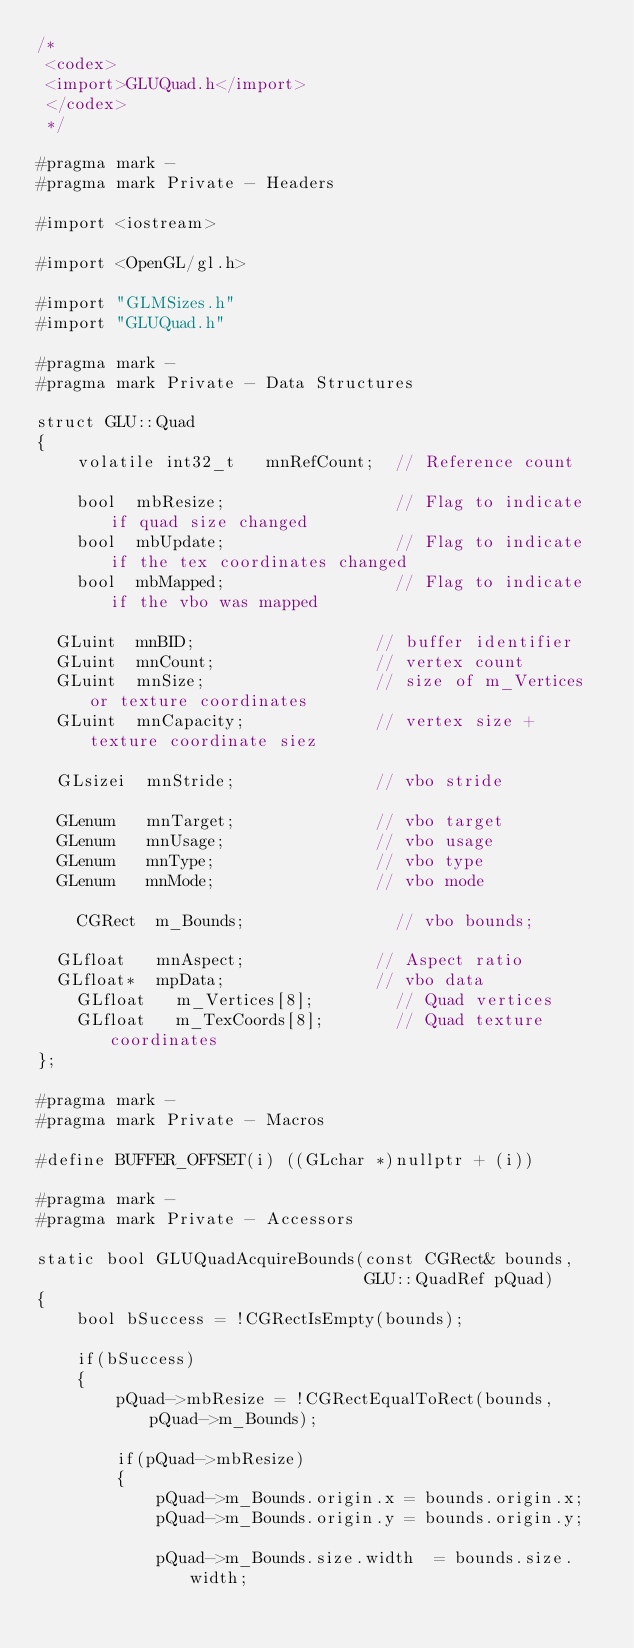Convert code to text. <code><loc_0><loc_0><loc_500><loc_500><_ObjectiveC_>/*
 <codex>
 <import>GLUQuad.h</import>
 </codex>
 */

#pragma mark -
#pragma mark Private - Headers

#import <iostream>

#import <OpenGL/gl.h>

#import "GLMSizes.h"
#import "GLUQuad.h"

#pragma mark -
#pragma mark Private - Data Structures

struct GLU::Quad
{
    volatile int32_t   mnRefCount;  // Reference count
    
    bool  mbResize;                 // Flag to indicate if quad size changed
    bool  mbUpdate;                 // Flag to indicate if the tex coordinates changed
    bool  mbMapped;                 // Flag to indicate if the vbo was mapped
    
	GLuint  mnBID;                  // buffer identifier
	GLuint  mnCount;                // vertex count
	GLuint  mnSize;                 // size of m_Vertices or texture coordinates
	GLuint  mnCapacity;             // vertex size + texture coordinate siez
    
	GLsizei  mnStride;              // vbo stride
    
	GLenum   mnTarget;              // vbo target
	GLenum   mnUsage;               // vbo usage
	GLenum   mnType;                // vbo type
	GLenum   mnMode;                // vbo mode
    
    CGRect  m_Bounds;               // vbo bounds;
    
	GLfloat   mnAspect;             // Aspect ratio
	GLfloat*  mpData;               // vbo data
    GLfloat   m_Vertices[8];        // Quad vertices
    GLfloat   m_TexCoords[8];       // Quad texture coordinates
};

#pragma mark -
#pragma mark Private - Macros

#define BUFFER_OFFSET(i) ((GLchar *)nullptr + (i))

#pragma mark -
#pragma mark Private - Accessors

static bool GLUQuadAcquireBounds(const CGRect& bounds,
                                 GLU::QuadRef pQuad)
{
    bool bSuccess = !CGRectIsEmpty(bounds);
    
    if(bSuccess)
    {
        pQuad->mbResize = !CGRectEqualToRect(bounds, pQuad->m_Bounds);
        
        if(pQuad->mbResize)
        {
            pQuad->m_Bounds.origin.x = bounds.origin.x;
            pQuad->m_Bounds.origin.y = bounds.origin.y;
            
            pQuad->m_Bounds.size.width  = bounds.size.width;</code> 